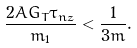<formula> <loc_0><loc_0><loc_500><loc_500>\frac { 2 \bar { A } G _ { T } \tau _ { n z } } { m _ { 1 } } < \frac { 1 } { 3 m } .</formula> 